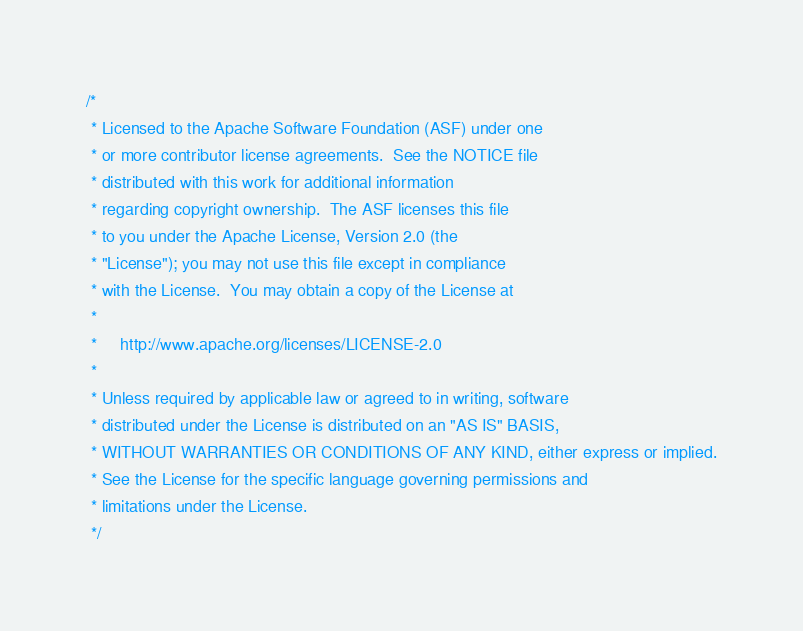Convert code to text. <code><loc_0><loc_0><loc_500><loc_500><_Java_>/*
 * Licensed to the Apache Software Foundation (ASF) under one
 * or more contributor license agreements.  See the NOTICE file
 * distributed with this work for additional information
 * regarding copyright ownership.  The ASF licenses this file
 * to you under the Apache License, Version 2.0 (the
 * "License"); you may not use this file except in compliance
 * with the License.  You may obtain a copy of the License at
 *
 *     http://www.apache.org/licenses/LICENSE-2.0
 *
 * Unless required by applicable law or agreed to in writing, software
 * distributed under the License is distributed on an "AS IS" BASIS,
 * WITHOUT WARRANTIES OR CONDITIONS OF ANY KIND, either express or implied.
 * See the License for the specific language governing permissions and
 * limitations under the License.
 */
</code> 